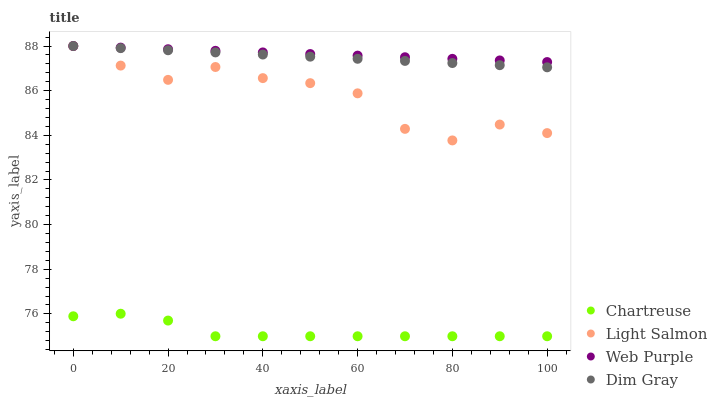Does Chartreuse have the minimum area under the curve?
Answer yes or no. Yes. Does Web Purple have the maximum area under the curve?
Answer yes or no. Yes. Does Dim Gray have the minimum area under the curve?
Answer yes or no. No. Does Dim Gray have the maximum area under the curve?
Answer yes or no. No. Is Dim Gray the smoothest?
Answer yes or no. Yes. Is Light Salmon the roughest?
Answer yes or no. Yes. Is Chartreuse the smoothest?
Answer yes or no. No. Is Chartreuse the roughest?
Answer yes or no. No. Does Chartreuse have the lowest value?
Answer yes or no. Yes. Does Dim Gray have the lowest value?
Answer yes or no. No. Does Light Salmon have the highest value?
Answer yes or no. Yes. Does Chartreuse have the highest value?
Answer yes or no. No. Is Chartreuse less than Light Salmon?
Answer yes or no. Yes. Is Dim Gray greater than Chartreuse?
Answer yes or no. Yes. Does Web Purple intersect Light Salmon?
Answer yes or no. Yes. Is Web Purple less than Light Salmon?
Answer yes or no. No. Is Web Purple greater than Light Salmon?
Answer yes or no. No. Does Chartreuse intersect Light Salmon?
Answer yes or no. No. 